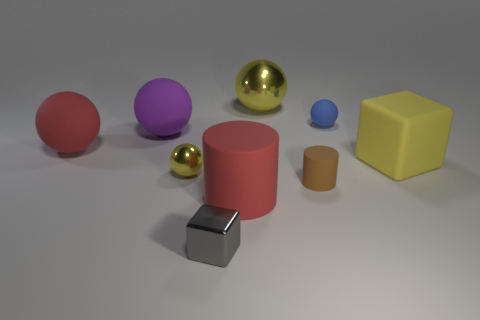Subtract all big purple rubber balls. How many balls are left? 4 Subtract all blue spheres. How many spheres are left? 4 Subtract all cylinders. How many objects are left? 7 Subtract all brown cubes. Subtract all green cylinders. How many cubes are left? 2 Subtract all gray blocks. How many yellow spheres are left? 2 Subtract all small matte balls. Subtract all tiny balls. How many objects are left? 6 Add 2 brown cylinders. How many brown cylinders are left? 3 Add 6 small brown metallic cubes. How many small brown metallic cubes exist? 6 Subtract 0 green cylinders. How many objects are left? 9 Subtract 2 blocks. How many blocks are left? 0 